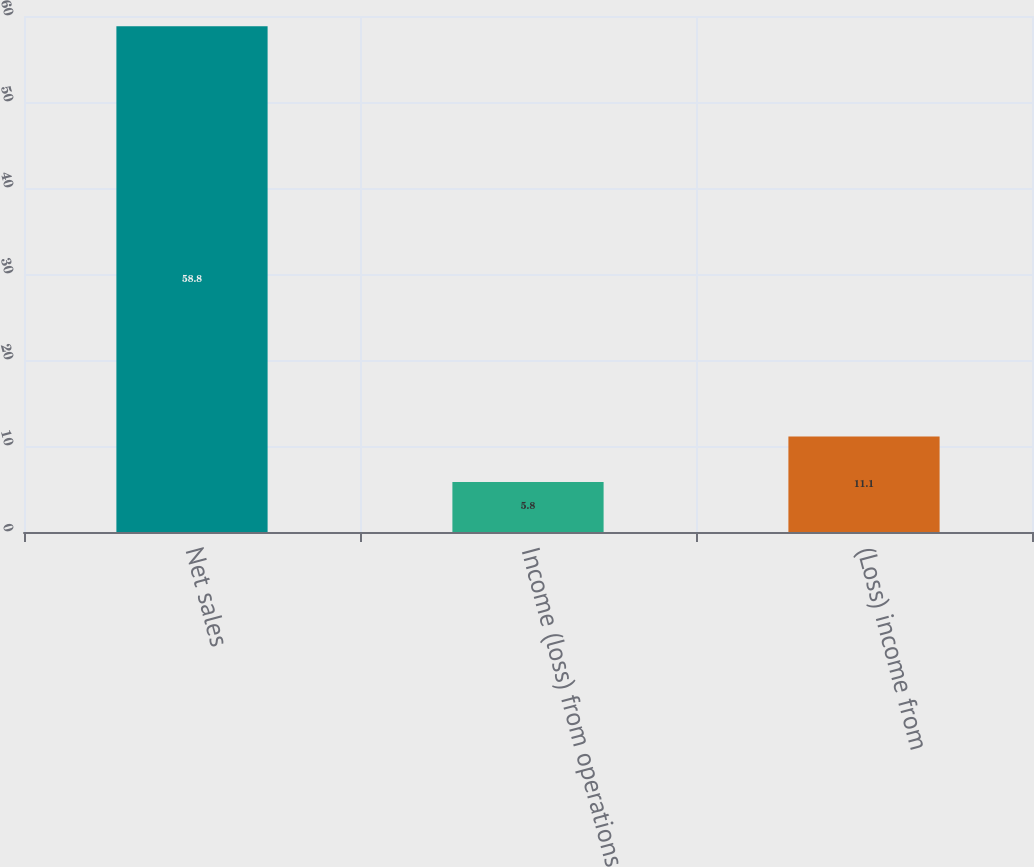Convert chart. <chart><loc_0><loc_0><loc_500><loc_500><bar_chart><fcel>Net sales<fcel>Income (loss) from operations<fcel>(Loss) income from<nl><fcel>58.8<fcel>5.8<fcel>11.1<nl></chart> 